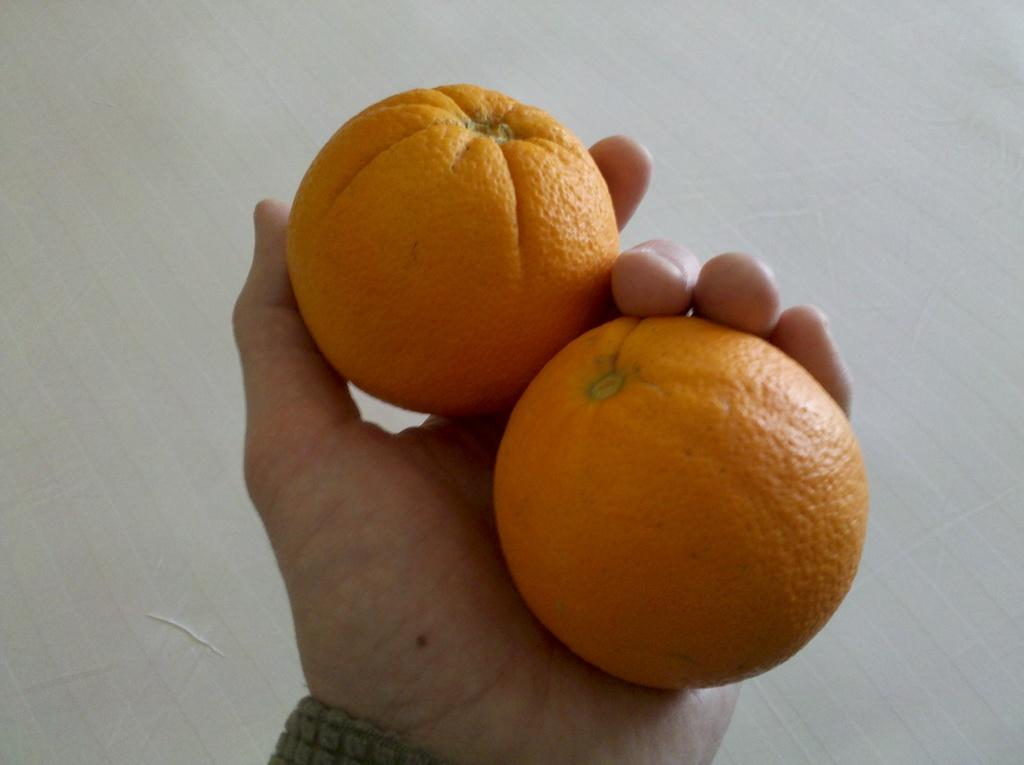What is being held by the hand in the image? There is a human hand holding two oranges in the image. What can be seen in the background of the image? The background of the image is white. What type of brake can be seen on the moon in the image? There is no brake or moon present in the image; it only features a human hand holding two oranges against a white background. 